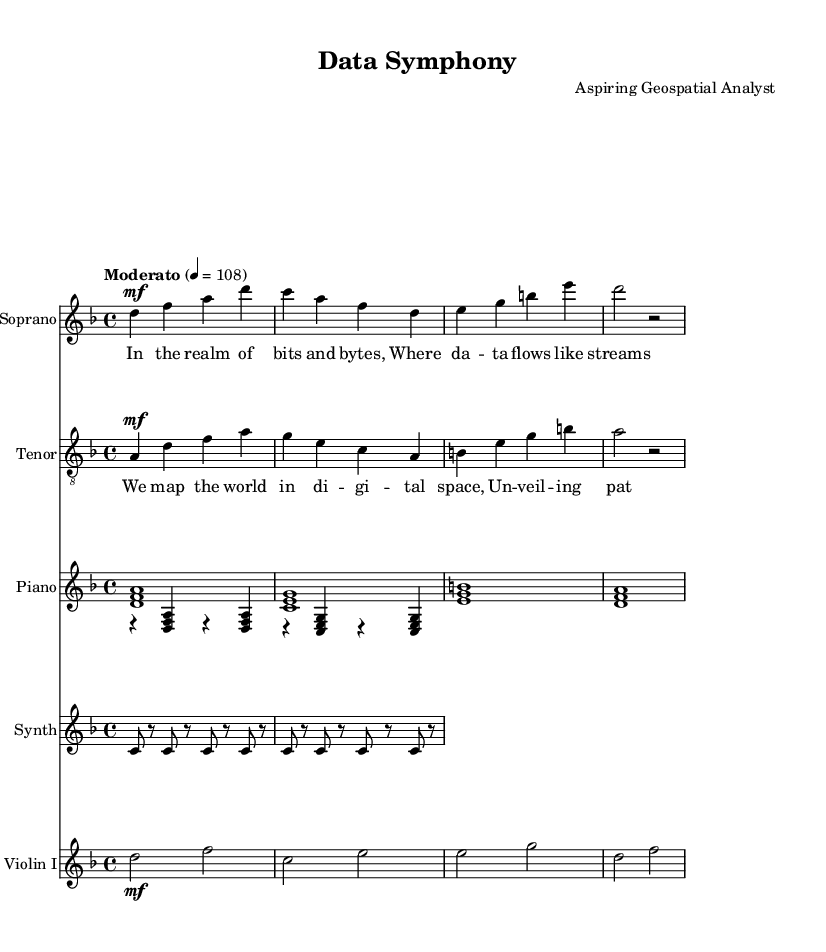What is the key signature of this music? The key signature is indicated by the key signature notation. In this sheet music, it shows two flats next to the treble clef, which indicates the key of D minor.
Answer: D minor What is the time signature of this piece? The time signature is noted at the beginning of the score. This piece has a time signature of 4 over 4, which means there are four beats in a measure, and the quarter note gets one beat.
Answer: 4/4 What is the tempo marking of this piece? The tempo marking is expressed at the beginning of the score with a specific term and metronome marking. Here, it mentions "Moderato" and "4 = 108," indicating a moderate speed of 108 beats per minute.
Answer: Moderato How many instruments are used in this score? By counting the distinct staff sections in the score, we identify Soprano, Tenor, Piano, Synth, and Violin, totaling five separate instruments.
Answer: Five What form of lyrics is present in this piece? The lyrics are specified under the soprano and tenor sections. They are in a structured lyric format, usual in operatic compositions, where the text is lyrical and set with the music.
Answer: Lyric form What thematic concept is explored in the lyrics? The lyrics indicate a theme of technology and data visualization, mentioning "bits and bytes" and "mapping the world in digital space," connecting to contemporary operatic explorations of technological advancement.
Answer: Technology 